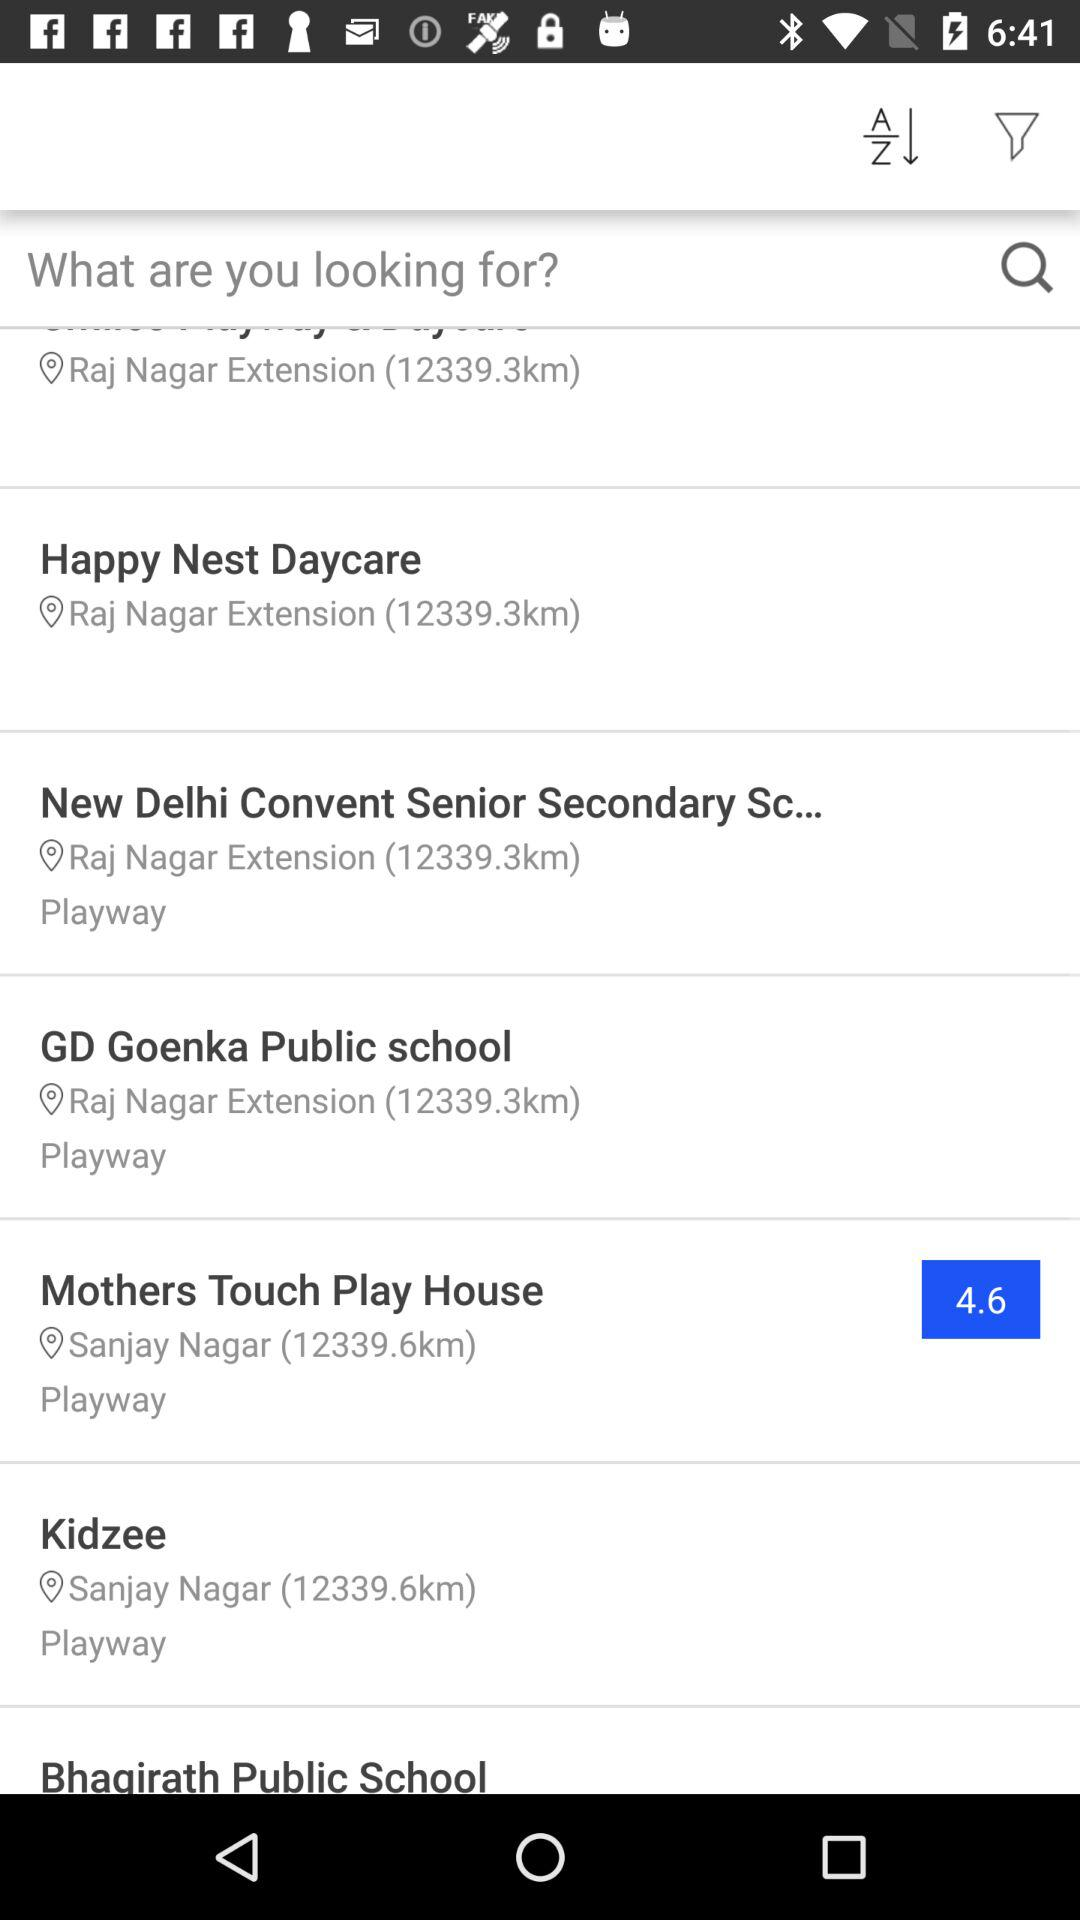What is the location of Kidzee? The location is "Sanjay Nagar". 